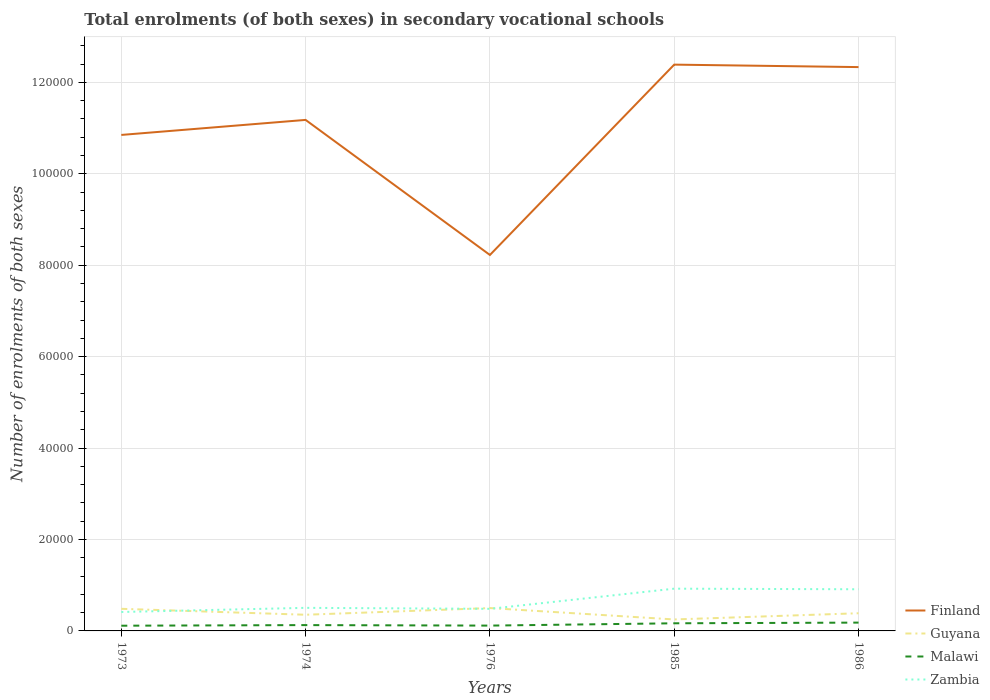Across all years, what is the maximum number of enrolments in secondary schools in Zambia?
Make the answer very short. 4140. In which year was the number of enrolments in secondary schools in Finland maximum?
Offer a terse response. 1976. What is the total number of enrolments in secondary schools in Guyana in the graph?
Keep it short and to the point. -165. What is the difference between the highest and the second highest number of enrolments in secondary schools in Finland?
Provide a short and direct response. 4.16e+04. Does the graph contain any zero values?
Ensure brevity in your answer.  No. Where does the legend appear in the graph?
Ensure brevity in your answer.  Bottom right. How are the legend labels stacked?
Keep it short and to the point. Vertical. What is the title of the graph?
Offer a very short reply. Total enrolments (of both sexes) in secondary vocational schools. What is the label or title of the Y-axis?
Ensure brevity in your answer.  Number of enrolments of both sexes. What is the Number of enrolments of both sexes in Finland in 1973?
Give a very brief answer. 1.08e+05. What is the Number of enrolments of both sexes in Guyana in 1973?
Keep it short and to the point. 4836. What is the Number of enrolments of both sexes in Malawi in 1973?
Give a very brief answer. 1142. What is the Number of enrolments of both sexes of Zambia in 1973?
Offer a very short reply. 4140. What is the Number of enrolments of both sexes of Finland in 1974?
Offer a terse response. 1.12e+05. What is the Number of enrolments of both sexes in Guyana in 1974?
Give a very brief answer. 3539. What is the Number of enrolments of both sexes in Malawi in 1974?
Offer a terse response. 1274. What is the Number of enrolments of both sexes of Zambia in 1974?
Provide a succinct answer. 5048. What is the Number of enrolments of both sexes of Finland in 1976?
Offer a terse response. 8.22e+04. What is the Number of enrolments of both sexes in Guyana in 1976?
Provide a succinct answer. 5001. What is the Number of enrolments of both sexes of Malawi in 1976?
Provide a succinct answer. 1165. What is the Number of enrolments of both sexes in Zambia in 1976?
Offer a very short reply. 4832. What is the Number of enrolments of both sexes in Finland in 1985?
Keep it short and to the point. 1.24e+05. What is the Number of enrolments of both sexes of Guyana in 1985?
Your answer should be compact. 2509. What is the Number of enrolments of both sexes of Malawi in 1985?
Make the answer very short. 1669. What is the Number of enrolments of both sexes of Zambia in 1985?
Give a very brief answer. 9241. What is the Number of enrolments of both sexes in Finland in 1986?
Give a very brief answer. 1.23e+05. What is the Number of enrolments of both sexes of Guyana in 1986?
Provide a short and direct response. 3867. What is the Number of enrolments of both sexes in Malawi in 1986?
Give a very brief answer. 1818. What is the Number of enrolments of both sexes in Zambia in 1986?
Provide a succinct answer. 9112. Across all years, what is the maximum Number of enrolments of both sexes of Finland?
Offer a terse response. 1.24e+05. Across all years, what is the maximum Number of enrolments of both sexes in Guyana?
Your answer should be compact. 5001. Across all years, what is the maximum Number of enrolments of both sexes of Malawi?
Keep it short and to the point. 1818. Across all years, what is the maximum Number of enrolments of both sexes in Zambia?
Provide a short and direct response. 9241. Across all years, what is the minimum Number of enrolments of both sexes in Finland?
Offer a very short reply. 8.22e+04. Across all years, what is the minimum Number of enrolments of both sexes in Guyana?
Your answer should be very brief. 2509. Across all years, what is the minimum Number of enrolments of both sexes in Malawi?
Offer a terse response. 1142. Across all years, what is the minimum Number of enrolments of both sexes in Zambia?
Your answer should be very brief. 4140. What is the total Number of enrolments of both sexes of Finland in the graph?
Your answer should be very brief. 5.50e+05. What is the total Number of enrolments of both sexes of Guyana in the graph?
Your response must be concise. 1.98e+04. What is the total Number of enrolments of both sexes of Malawi in the graph?
Your response must be concise. 7068. What is the total Number of enrolments of both sexes in Zambia in the graph?
Keep it short and to the point. 3.24e+04. What is the difference between the Number of enrolments of both sexes of Finland in 1973 and that in 1974?
Keep it short and to the point. -3286. What is the difference between the Number of enrolments of both sexes of Guyana in 1973 and that in 1974?
Make the answer very short. 1297. What is the difference between the Number of enrolments of both sexes of Malawi in 1973 and that in 1974?
Keep it short and to the point. -132. What is the difference between the Number of enrolments of both sexes in Zambia in 1973 and that in 1974?
Keep it short and to the point. -908. What is the difference between the Number of enrolments of both sexes of Finland in 1973 and that in 1976?
Your answer should be compact. 2.63e+04. What is the difference between the Number of enrolments of both sexes in Guyana in 1973 and that in 1976?
Your answer should be very brief. -165. What is the difference between the Number of enrolments of both sexes of Malawi in 1973 and that in 1976?
Keep it short and to the point. -23. What is the difference between the Number of enrolments of both sexes in Zambia in 1973 and that in 1976?
Your answer should be very brief. -692. What is the difference between the Number of enrolments of both sexes of Finland in 1973 and that in 1985?
Your response must be concise. -1.54e+04. What is the difference between the Number of enrolments of both sexes in Guyana in 1973 and that in 1985?
Provide a short and direct response. 2327. What is the difference between the Number of enrolments of both sexes of Malawi in 1973 and that in 1985?
Provide a succinct answer. -527. What is the difference between the Number of enrolments of both sexes in Zambia in 1973 and that in 1985?
Offer a very short reply. -5101. What is the difference between the Number of enrolments of both sexes in Finland in 1973 and that in 1986?
Ensure brevity in your answer.  -1.48e+04. What is the difference between the Number of enrolments of both sexes of Guyana in 1973 and that in 1986?
Your answer should be compact. 969. What is the difference between the Number of enrolments of both sexes in Malawi in 1973 and that in 1986?
Provide a succinct answer. -676. What is the difference between the Number of enrolments of both sexes in Zambia in 1973 and that in 1986?
Keep it short and to the point. -4972. What is the difference between the Number of enrolments of both sexes of Finland in 1974 and that in 1976?
Make the answer very short. 2.95e+04. What is the difference between the Number of enrolments of both sexes in Guyana in 1974 and that in 1976?
Provide a short and direct response. -1462. What is the difference between the Number of enrolments of both sexes of Malawi in 1974 and that in 1976?
Provide a succinct answer. 109. What is the difference between the Number of enrolments of both sexes in Zambia in 1974 and that in 1976?
Offer a very short reply. 216. What is the difference between the Number of enrolments of both sexes in Finland in 1974 and that in 1985?
Provide a succinct answer. -1.21e+04. What is the difference between the Number of enrolments of both sexes in Guyana in 1974 and that in 1985?
Keep it short and to the point. 1030. What is the difference between the Number of enrolments of both sexes in Malawi in 1974 and that in 1985?
Ensure brevity in your answer.  -395. What is the difference between the Number of enrolments of both sexes of Zambia in 1974 and that in 1985?
Give a very brief answer. -4193. What is the difference between the Number of enrolments of both sexes in Finland in 1974 and that in 1986?
Keep it short and to the point. -1.16e+04. What is the difference between the Number of enrolments of both sexes of Guyana in 1974 and that in 1986?
Provide a succinct answer. -328. What is the difference between the Number of enrolments of both sexes of Malawi in 1974 and that in 1986?
Provide a succinct answer. -544. What is the difference between the Number of enrolments of both sexes of Zambia in 1974 and that in 1986?
Ensure brevity in your answer.  -4064. What is the difference between the Number of enrolments of both sexes in Finland in 1976 and that in 1985?
Provide a succinct answer. -4.16e+04. What is the difference between the Number of enrolments of both sexes in Guyana in 1976 and that in 1985?
Offer a very short reply. 2492. What is the difference between the Number of enrolments of both sexes of Malawi in 1976 and that in 1985?
Keep it short and to the point. -504. What is the difference between the Number of enrolments of both sexes of Zambia in 1976 and that in 1985?
Your response must be concise. -4409. What is the difference between the Number of enrolments of both sexes of Finland in 1976 and that in 1986?
Give a very brief answer. -4.11e+04. What is the difference between the Number of enrolments of both sexes in Guyana in 1976 and that in 1986?
Give a very brief answer. 1134. What is the difference between the Number of enrolments of both sexes in Malawi in 1976 and that in 1986?
Offer a very short reply. -653. What is the difference between the Number of enrolments of both sexes in Zambia in 1976 and that in 1986?
Provide a succinct answer. -4280. What is the difference between the Number of enrolments of both sexes in Finland in 1985 and that in 1986?
Provide a short and direct response. 540. What is the difference between the Number of enrolments of both sexes of Guyana in 1985 and that in 1986?
Keep it short and to the point. -1358. What is the difference between the Number of enrolments of both sexes of Malawi in 1985 and that in 1986?
Offer a terse response. -149. What is the difference between the Number of enrolments of both sexes in Zambia in 1985 and that in 1986?
Your answer should be very brief. 129. What is the difference between the Number of enrolments of both sexes in Finland in 1973 and the Number of enrolments of both sexes in Guyana in 1974?
Give a very brief answer. 1.05e+05. What is the difference between the Number of enrolments of both sexes of Finland in 1973 and the Number of enrolments of both sexes of Malawi in 1974?
Your answer should be very brief. 1.07e+05. What is the difference between the Number of enrolments of both sexes in Finland in 1973 and the Number of enrolments of both sexes in Zambia in 1974?
Offer a terse response. 1.03e+05. What is the difference between the Number of enrolments of both sexes in Guyana in 1973 and the Number of enrolments of both sexes in Malawi in 1974?
Your response must be concise. 3562. What is the difference between the Number of enrolments of both sexes in Guyana in 1973 and the Number of enrolments of both sexes in Zambia in 1974?
Make the answer very short. -212. What is the difference between the Number of enrolments of both sexes of Malawi in 1973 and the Number of enrolments of both sexes of Zambia in 1974?
Your answer should be very brief. -3906. What is the difference between the Number of enrolments of both sexes of Finland in 1973 and the Number of enrolments of both sexes of Guyana in 1976?
Offer a terse response. 1.03e+05. What is the difference between the Number of enrolments of both sexes in Finland in 1973 and the Number of enrolments of both sexes in Malawi in 1976?
Ensure brevity in your answer.  1.07e+05. What is the difference between the Number of enrolments of both sexes in Finland in 1973 and the Number of enrolments of both sexes in Zambia in 1976?
Your answer should be very brief. 1.04e+05. What is the difference between the Number of enrolments of both sexes of Guyana in 1973 and the Number of enrolments of both sexes of Malawi in 1976?
Provide a succinct answer. 3671. What is the difference between the Number of enrolments of both sexes of Guyana in 1973 and the Number of enrolments of both sexes of Zambia in 1976?
Make the answer very short. 4. What is the difference between the Number of enrolments of both sexes in Malawi in 1973 and the Number of enrolments of both sexes in Zambia in 1976?
Ensure brevity in your answer.  -3690. What is the difference between the Number of enrolments of both sexes of Finland in 1973 and the Number of enrolments of both sexes of Guyana in 1985?
Your answer should be very brief. 1.06e+05. What is the difference between the Number of enrolments of both sexes of Finland in 1973 and the Number of enrolments of both sexes of Malawi in 1985?
Provide a succinct answer. 1.07e+05. What is the difference between the Number of enrolments of both sexes in Finland in 1973 and the Number of enrolments of both sexes in Zambia in 1985?
Ensure brevity in your answer.  9.92e+04. What is the difference between the Number of enrolments of both sexes of Guyana in 1973 and the Number of enrolments of both sexes of Malawi in 1985?
Keep it short and to the point. 3167. What is the difference between the Number of enrolments of both sexes of Guyana in 1973 and the Number of enrolments of both sexes of Zambia in 1985?
Provide a short and direct response. -4405. What is the difference between the Number of enrolments of both sexes of Malawi in 1973 and the Number of enrolments of both sexes of Zambia in 1985?
Your answer should be compact. -8099. What is the difference between the Number of enrolments of both sexes of Finland in 1973 and the Number of enrolments of both sexes of Guyana in 1986?
Offer a terse response. 1.05e+05. What is the difference between the Number of enrolments of both sexes of Finland in 1973 and the Number of enrolments of both sexes of Malawi in 1986?
Make the answer very short. 1.07e+05. What is the difference between the Number of enrolments of both sexes in Finland in 1973 and the Number of enrolments of both sexes in Zambia in 1986?
Give a very brief answer. 9.94e+04. What is the difference between the Number of enrolments of both sexes of Guyana in 1973 and the Number of enrolments of both sexes of Malawi in 1986?
Your response must be concise. 3018. What is the difference between the Number of enrolments of both sexes in Guyana in 1973 and the Number of enrolments of both sexes in Zambia in 1986?
Offer a very short reply. -4276. What is the difference between the Number of enrolments of both sexes in Malawi in 1973 and the Number of enrolments of both sexes in Zambia in 1986?
Ensure brevity in your answer.  -7970. What is the difference between the Number of enrolments of both sexes of Finland in 1974 and the Number of enrolments of both sexes of Guyana in 1976?
Ensure brevity in your answer.  1.07e+05. What is the difference between the Number of enrolments of both sexes of Finland in 1974 and the Number of enrolments of both sexes of Malawi in 1976?
Your answer should be very brief. 1.11e+05. What is the difference between the Number of enrolments of both sexes of Finland in 1974 and the Number of enrolments of both sexes of Zambia in 1976?
Make the answer very short. 1.07e+05. What is the difference between the Number of enrolments of both sexes of Guyana in 1974 and the Number of enrolments of both sexes of Malawi in 1976?
Your answer should be compact. 2374. What is the difference between the Number of enrolments of both sexes of Guyana in 1974 and the Number of enrolments of both sexes of Zambia in 1976?
Your answer should be compact. -1293. What is the difference between the Number of enrolments of both sexes of Malawi in 1974 and the Number of enrolments of both sexes of Zambia in 1976?
Your response must be concise. -3558. What is the difference between the Number of enrolments of both sexes in Finland in 1974 and the Number of enrolments of both sexes in Guyana in 1985?
Ensure brevity in your answer.  1.09e+05. What is the difference between the Number of enrolments of both sexes of Finland in 1974 and the Number of enrolments of both sexes of Malawi in 1985?
Ensure brevity in your answer.  1.10e+05. What is the difference between the Number of enrolments of both sexes of Finland in 1974 and the Number of enrolments of both sexes of Zambia in 1985?
Your response must be concise. 1.03e+05. What is the difference between the Number of enrolments of both sexes of Guyana in 1974 and the Number of enrolments of both sexes of Malawi in 1985?
Offer a very short reply. 1870. What is the difference between the Number of enrolments of both sexes of Guyana in 1974 and the Number of enrolments of both sexes of Zambia in 1985?
Offer a very short reply. -5702. What is the difference between the Number of enrolments of both sexes in Malawi in 1974 and the Number of enrolments of both sexes in Zambia in 1985?
Your response must be concise. -7967. What is the difference between the Number of enrolments of both sexes of Finland in 1974 and the Number of enrolments of both sexes of Guyana in 1986?
Your answer should be compact. 1.08e+05. What is the difference between the Number of enrolments of both sexes in Finland in 1974 and the Number of enrolments of both sexes in Malawi in 1986?
Provide a succinct answer. 1.10e+05. What is the difference between the Number of enrolments of both sexes in Finland in 1974 and the Number of enrolments of both sexes in Zambia in 1986?
Ensure brevity in your answer.  1.03e+05. What is the difference between the Number of enrolments of both sexes of Guyana in 1974 and the Number of enrolments of both sexes of Malawi in 1986?
Provide a short and direct response. 1721. What is the difference between the Number of enrolments of both sexes in Guyana in 1974 and the Number of enrolments of both sexes in Zambia in 1986?
Give a very brief answer. -5573. What is the difference between the Number of enrolments of both sexes of Malawi in 1974 and the Number of enrolments of both sexes of Zambia in 1986?
Offer a terse response. -7838. What is the difference between the Number of enrolments of both sexes of Finland in 1976 and the Number of enrolments of both sexes of Guyana in 1985?
Ensure brevity in your answer.  7.97e+04. What is the difference between the Number of enrolments of both sexes of Finland in 1976 and the Number of enrolments of both sexes of Malawi in 1985?
Provide a succinct answer. 8.06e+04. What is the difference between the Number of enrolments of both sexes of Finland in 1976 and the Number of enrolments of both sexes of Zambia in 1985?
Your response must be concise. 7.30e+04. What is the difference between the Number of enrolments of both sexes in Guyana in 1976 and the Number of enrolments of both sexes in Malawi in 1985?
Make the answer very short. 3332. What is the difference between the Number of enrolments of both sexes of Guyana in 1976 and the Number of enrolments of both sexes of Zambia in 1985?
Offer a very short reply. -4240. What is the difference between the Number of enrolments of both sexes of Malawi in 1976 and the Number of enrolments of both sexes of Zambia in 1985?
Provide a succinct answer. -8076. What is the difference between the Number of enrolments of both sexes of Finland in 1976 and the Number of enrolments of both sexes of Guyana in 1986?
Your answer should be very brief. 7.84e+04. What is the difference between the Number of enrolments of both sexes in Finland in 1976 and the Number of enrolments of both sexes in Malawi in 1986?
Provide a short and direct response. 8.04e+04. What is the difference between the Number of enrolments of both sexes in Finland in 1976 and the Number of enrolments of both sexes in Zambia in 1986?
Provide a short and direct response. 7.31e+04. What is the difference between the Number of enrolments of both sexes of Guyana in 1976 and the Number of enrolments of both sexes of Malawi in 1986?
Your response must be concise. 3183. What is the difference between the Number of enrolments of both sexes in Guyana in 1976 and the Number of enrolments of both sexes in Zambia in 1986?
Provide a succinct answer. -4111. What is the difference between the Number of enrolments of both sexes in Malawi in 1976 and the Number of enrolments of both sexes in Zambia in 1986?
Keep it short and to the point. -7947. What is the difference between the Number of enrolments of both sexes of Finland in 1985 and the Number of enrolments of both sexes of Guyana in 1986?
Your response must be concise. 1.20e+05. What is the difference between the Number of enrolments of both sexes of Finland in 1985 and the Number of enrolments of both sexes of Malawi in 1986?
Your answer should be compact. 1.22e+05. What is the difference between the Number of enrolments of both sexes in Finland in 1985 and the Number of enrolments of both sexes in Zambia in 1986?
Make the answer very short. 1.15e+05. What is the difference between the Number of enrolments of both sexes of Guyana in 1985 and the Number of enrolments of both sexes of Malawi in 1986?
Provide a short and direct response. 691. What is the difference between the Number of enrolments of both sexes of Guyana in 1985 and the Number of enrolments of both sexes of Zambia in 1986?
Make the answer very short. -6603. What is the difference between the Number of enrolments of both sexes of Malawi in 1985 and the Number of enrolments of both sexes of Zambia in 1986?
Your answer should be compact. -7443. What is the average Number of enrolments of both sexes in Finland per year?
Give a very brief answer. 1.10e+05. What is the average Number of enrolments of both sexes of Guyana per year?
Offer a very short reply. 3950.4. What is the average Number of enrolments of both sexes in Malawi per year?
Give a very brief answer. 1413.6. What is the average Number of enrolments of both sexes in Zambia per year?
Keep it short and to the point. 6474.6. In the year 1973, what is the difference between the Number of enrolments of both sexes in Finland and Number of enrolments of both sexes in Guyana?
Your answer should be very brief. 1.04e+05. In the year 1973, what is the difference between the Number of enrolments of both sexes of Finland and Number of enrolments of both sexes of Malawi?
Give a very brief answer. 1.07e+05. In the year 1973, what is the difference between the Number of enrolments of both sexes of Finland and Number of enrolments of both sexes of Zambia?
Offer a very short reply. 1.04e+05. In the year 1973, what is the difference between the Number of enrolments of both sexes of Guyana and Number of enrolments of both sexes of Malawi?
Your answer should be compact. 3694. In the year 1973, what is the difference between the Number of enrolments of both sexes of Guyana and Number of enrolments of both sexes of Zambia?
Ensure brevity in your answer.  696. In the year 1973, what is the difference between the Number of enrolments of both sexes of Malawi and Number of enrolments of both sexes of Zambia?
Keep it short and to the point. -2998. In the year 1974, what is the difference between the Number of enrolments of both sexes of Finland and Number of enrolments of both sexes of Guyana?
Offer a very short reply. 1.08e+05. In the year 1974, what is the difference between the Number of enrolments of both sexes of Finland and Number of enrolments of both sexes of Malawi?
Your answer should be very brief. 1.11e+05. In the year 1974, what is the difference between the Number of enrolments of both sexes of Finland and Number of enrolments of both sexes of Zambia?
Provide a short and direct response. 1.07e+05. In the year 1974, what is the difference between the Number of enrolments of both sexes of Guyana and Number of enrolments of both sexes of Malawi?
Offer a very short reply. 2265. In the year 1974, what is the difference between the Number of enrolments of both sexes of Guyana and Number of enrolments of both sexes of Zambia?
Provide a short and direct response. -1509. In the year 1974, what is the difference between the Number of enrolments of both sexes in Malawi and Number of enrolments of both sexes in Zambia?
Offer a very short reply. -3774. In the year 1976, what is the difference between the Number of enrolments of both sexes in Finland and Number of enrolments of both sexes in Guyana?
Ensure brevity in your answer.  7.72e+04. In the year 1976, what is the difference between the Number of enrolments of both sexes in Finland and Number of enrolments of both sexes in Malawi?
Offer a terse response. 8.11e+04. In the year 1976, what is the difference between the Number of enrolments of both sexes in Finland and Number of enrolments of both sexes in Zambia?
Your answer should be compact. 7.74e+04. In the year 1976, what is the difference between the Number of enrolments of both sexes in Guyana and Number of enrolments of both sexes in Malawi?
Offer a terse response. 3836. In the year 1976, what is the difference between the Number of enrolments of both sexes in Guyana and Number of enrolments of both sexes in Zambia?
Your response must be concise. 169. In the year 1976, what is the difference between the Number of enrolments of both sexes in Malawi and Number of enrolments of both sexes in Zambia?
Your answer should be compact. -3667. In the year 1985, what is the difference between the Number of enrolments of both sexes of Finland and Number of enrolments of both sexes of Guyana?
Keep it short and to the point. 1.21e+05. In the year 1985, what is the difference between the Number of enrolments of both sexes of Finland and Number of enrolments of both sexes of Malawi?
Ensure brevity in your answer.  1.22e+05. In the year 1985, what is the difference between the Number of enrolments of both sexes in Finland and Number of enrolments of both sexes in Zambia?
Give a very brief answer. 1.15e+05. In the year 1985, what is the difference between the Number of enrolments of both sexes in Guyana and Number of enrolments of both sexes in Malawi?
Ensure brevity in your answer.  840. In the year 1985, what is the difference between the Number of enrolments of both sexes of Guyana and Number of enrolments of both sexes of Zambia?
Provide a short and direct response. -6732. In the year 1985, what is the difference between the Number of enrolments of both sexes in Malawi and Number of enrolments of both sexes in Zambia?
Ensure brevity in your answer.  -7572. In the year 1986, what is the difference between the Number of enrolments of both sexes of Finland and Number of enrolments of both sexes of Guyana?
Offer a terse response. 1.19e+05. In the year 1986, what is the difference between the Number of enrolments of both sexes in Finland and Number of enrolments of both sexes in Malawi?
Provide a short and direct response. 1.22e+05. In the year 1986, what is the difference between the Number of enrolments of both sexes of Finland and Number of enrolments of both sexes of Zambia?
Offer a very short reply. 1.14e+05. In the year 1986, what is the difference between the Number of enrolments of both sexes in Guyana and Number of enrolments of both sexes in Malawi?
Keep it short and to the point. 2049. In the year 1986, what is the difference between the Number of enrolments of both sexes of Guyana and Number of enrolments of both sexes of Zambia?
Your response must be concise. -5245. In the year 1986, what is the difference between the Number of enrolments of both sexes in Malawi and Number of enrolments of both sexes in Zambia?
Provide a succinct answer. -7294. What is the ratio of the Number of enrolments of both sexes in Finland in 1973 to that in 1974?
Offer a terse response. 0.97. What is the ratio of the Number of enrolments of both sexes in Guyana in 1973 to that in 1974?
Offer a terse response. 1.37. What is the ratio of the Number of enrolments of both sexes in Malawi in 1973 to that in 1974?
Make the answer very short. 0.9. What is the ratio of the Number of enrolments of both sexes in Zambia in 1973 to that in 1974?
Your response must be concise. 0.82. What is the ratio of the Number of enrolments of both sexes of Finland in 1973 to that in 1976?
Give a very brief answer. 1.32. What is the ratio of the Number of enrolments of both sexes of Guyana in 1973 to that in 1976?
Your answer should be very brief. 0.97. What is the ratio of the Number of enrolments of both sexes of Malawi in 1973 to that in 1976?
Make the answer very short. 0.98. What is the ratio of the Number of enrolments of both sexes in Zambia in 1973 to that in 1976?
Make the answer very short. 0.86. What is the ratio of the Number of enrolments of both sexes of Finland in 1973 to that in 1985?
Offer a terse response. 0.88. What is the ratio of the Number of enrolments of both sexes in Guyana in 1973 to that in 1985?
Your answer should be very brief. 1.93. What is the ratio of the Number of enrolments of both sexes in Malawi in 1973 to that in 1985?
Offer a very short reply. 0.68. What is the ratio of the Number of enrolments of both sexes of Zambia in 1973 to that in 1985?
Provide a succinct answer. 0.45. What is the ratio of the Number of enrolments of both sexes of Finland in 1973 to that in 1986?
Provide a succinct answer. 0.88. What is the ratio of the Number of enrolments of both sexes of Guyana in 1973 to that in 1986?
Provide a succinct answer. 1.25. What is the ratio of the Number of enrolments of both sexes in Malawi in 1973 to that in 1986?
Ensure brevity in your answer.  0.63. What is the ratio of the Number of enrolments of both sexes in Zambia in 1973 to that in 1986?
Your response must be concise. 0.45. What is the ratio of the Number of enrolments of both sexes of Finland in 1974 to that in 1976?
Make the answer very short. 1.36. What is the ratio of the Number of enrolments of both sexes of Guyana in 1974 to that in 1976?
Offer a very short reply. 0.71. What is the ratio of the Number of enrolments of both sexes in Malawi in 1974 to that in 1976?
Make the answer very short. 1.09. What is the ratio of the Number of enrolments of both sexes of Zambia in 1974 to that in 1976?
Your response must be concise. 1.04. What is the ratio of the Number of enrolments of both sexes in Finland in 1974 to that in 1985?
Provide a short and direct response. 0.9. What is the ratio of the Number of enrolments of both sexes of Guyana in 1974 to that in 1985?
Your answer should be very brief. 1.41. What is the ratio of the Number of enrolments of both sexes of Malawi in 1974 to that in 1985?
Your response must be concise. 0.76. What is the ratio of the Number of enrolments of both sexes in Zambia in 1974 to that in 1985?
Give a very brief answer. 0.55. What is the ratio of the Number of enrolments of both sexes in Finland in 1974 to that in 1986?
Your answer should be compact. 0.91. What is the ratio of the Number of enrolments of both sexes in Guyana in 1974 to that in 1986?
Offer a very short reply. 0.92. What is the ratio of the Number of enrolments of both sexes in Malawi in 1974 to that in 1986?
Provide a succinct answer. 0.7. What is the ratio of the Number of enrolments of both sexes in Zambia in 1974 to that in 1986?
Your answer should be very brief. 0.55. What is the ratio of the Number of enrolments of both sexes in Finland in 1976 to that in 1985?
Your answer should be very brief. 0.66. What is the ratio of the Number of enrolments of both sexes in Guyana in 1976 to that in 1985?
Your answer should be very brief. 1.99. What is the ratio of the Number of enrolments of both sexes in Malawi in 1976 to that in 1985?
Provide a short and direct response. 0.7. What is the ratio of the Number of enrolments of both sexes of Zambia in 1976 to that in 1985?
Make the answer very short. 0.52. What is the ratio of the Number of enrolments of both sexes in Finland in 1976 to that in 1986?
Offer a terse response. 0.67. What is the ratio of the Number of enrolments of both sexes of Guyana in 1976 to that in 1986?
Make the answer very short. 1.29. What is the ratio of the Number of enrolments of both sexes in Malawi in 1976 to that in 1986?
Offer a very short reply. 0.64. What is the ratio of the Number of enrolments of both sexes in Zambia in 1976 to that in 1986?
Offer a very short reply. 0.53. What is the ratio of the Number of enrolments of both sexes in Guyana in 1985 to that in 1986?
Your answer should be very brief. 0.65. What is the ratio of the Number of enrolments of both sexes of Malawi in 1985 to that in 1986?
Offer a terse response. 0.92. What is the ratio of the Number of enrolments of both sexes in Zambia in 1985 to that in 1986?
Make the answer very short. 1.01. What is the difference between the highest and the second highest Number of enrolments of both sexes in Finland?
Offer a terse response. 540. What is the difference between the highest and the second highest Number of enrolments of both sexes of Guyana?
Offer a terse response. 165. What is the difference between the highest and the second highest Number of enrolments of both sexes in Malawi?
Offer a terse response. 149. What is the difference between the highest and the second highest Number of enrolments of both sexes in Zambia?
Give a very brief answer. 129. What is the difference between the highest and the lowest Number of enrolments of both sexes in Finland?
Your answer should be very brief. 4.16e+04. What is the difference between the highest and the lowest Number of enrolments of both sexes of Guyana?
Offer a terse response. 2492. What is the difference between the highest and the lowest Number of enrolments of both sexes in Malawi?
Your answer should be compact. 676. What is the difference between the highest and the lowest Number of enrolments of both sexes in Zambia?
Ensure brevity in your answer.  5101. 